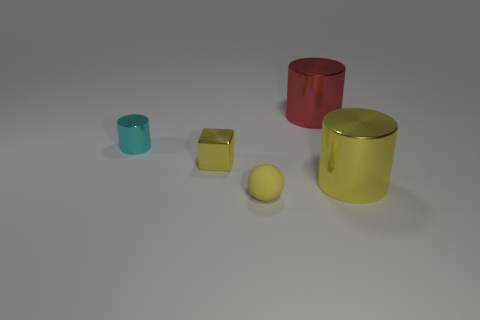Is there anything else that is made of the same material as the small yellow ball?
Keep it short and to the point. No. There is a small thing in front of the yellow metallic block; is it the same color as the tiny cube?
Give a very brief answer. Yes. There is a yellow thing that is the same shape as the red metal thing; what is its size?
Give a very brief answer. Large. What is the material of the yellow sphere that is left of the large cylinder behind the yellow shiny cylinder right of the tiny yellow rubber object?
Make the answer very short. Rubber. Is the number of large objects that are in front of the tiny rubber sphere greater than the number of yellow metallic cylinders behind the large red cylinder?
Make the answer very short. No. Do the yellow sphere and the red object have the same size?
Keep it short and to the point. No. What color is the small thing that is the same shape as the large red metal object?
Your answer should be compact. Cyan. How many rubber balls have the same color as the matte thing?
Your answer should be very brief. 0. Is the number of shiny cylinders that are behind the matte object greater than the number of large blue things?
Provide a short and direct response. Yes. There is a big cylinder that is behind the large cylinder in front of the cyan object; what color is it?
Give a very brief answer. Red. 